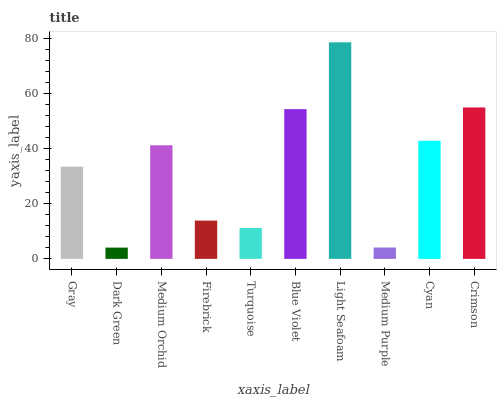Is Medium Orchid the minimum?
Answer yes or no. No. Is Medium Orchid the maximum?
Answer yes or no. No. Is Medium Orchid greater than Dark Green?
Answer yes or no. Yes. Is Dark Green less than Medium Orchid?
Answer yes or no. Yes. Is Dark Green greater than Medium Orchid?
Answer yes or no. No. Is Medium Orchid less than Dark Green?
Answer yes or no. No. Is Medium Orchid the high median?
Answer yes or no. Yes. Is Gray the low median?
Answer yes or no. Yes. Is Cyan the high median?
Answer yes or no. No. Is Light Seafoam the low median?
Answer yes or no. No. 